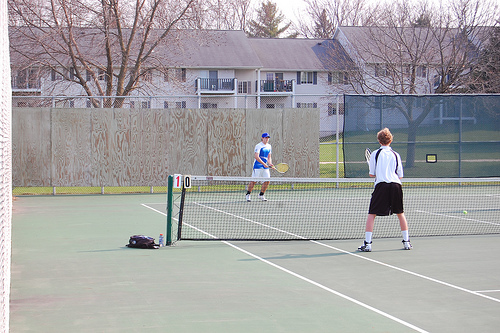How many people are in this photo? There are two people in the photo, engaged in a game of tennis on an outdoor court. 